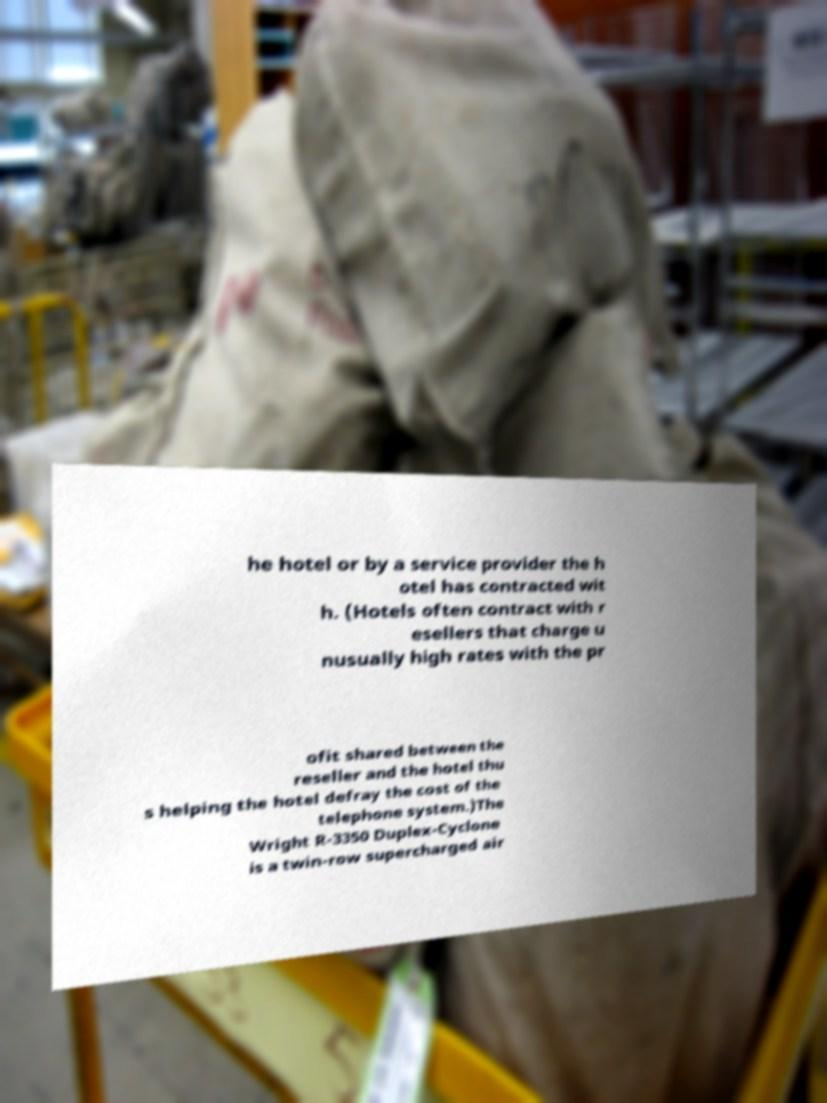There's text embedded in this image that I need extracted. Can you transcribe it verbatim? he hotel or by a service provider the h otel has contracted wit h. (Hotels often contract with r esellers that charge u nusually high rates with the pr ofit shared between the reseller and the hotel thu s helping the hotel defray the cost of the telephone system.)The Wright R-3350 Duplex-Cyclone is a twin-row supercharged air 